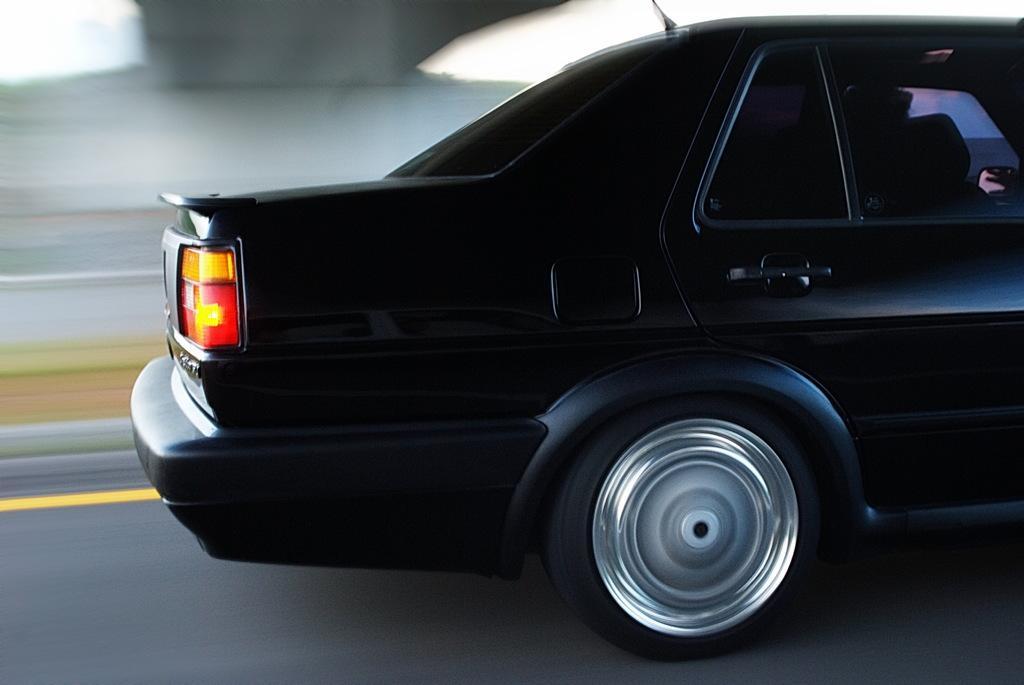In one or two sentences, can you explain what this image depicts? In this image I can see a car which is black, red and yellow in color is on the road. I can see the blurry background. 